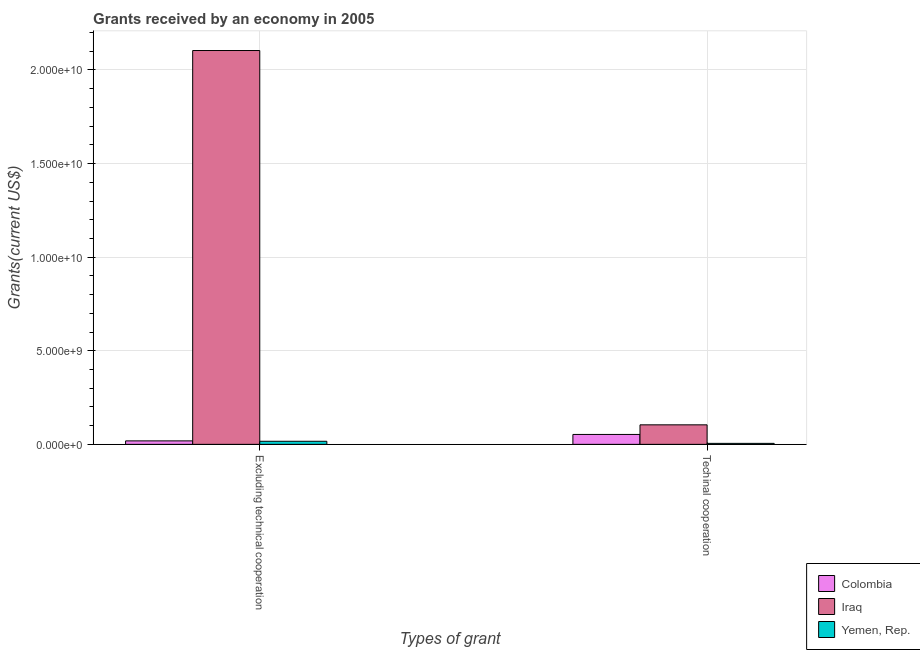How many bars are there on the 2nd tick from the left?
Offer a very short reply. 3. How many bars are there on the 1st tick from the right?
Ensure brevity in your answer.  3. What is the label of the 2nd group of bars from the left?
Your response must be concise. Techinal cooperation. What is the amount of grants received(excluding technical cooperation) in Colombia?
Provide a succinct answer. 1.86e+08. Across all countries, what is the maximum amount of grants received(excluding technical cooperation)?
Ensure brevity in your answer.  2.10e+1. Across all countries, what is the minimum amount of grants received(excluding technical cooperation)?
Keep it short and to the point. 1.65e+08. In which country was the amount of grants received(excluding technical cooperation) maximum?
Keep it short and to the point. Iraq. In which country was the amount of grants received(excluding technical cooperation) minimum?
Provide a short and direct response. Yemen, Rep. What is the total amount of grants received(excluding technical cooperation) in the graph?
Provide a short and direct response. 2.14e+1. What is the difference between the amount of grants received(excluding technical cooperation) in Colombia and that in Yemen, Rep.?
Give a very brief answer. 2.10e+07. What is the difference between the amount of grants received(including technical cooperation) in Colombia and the amount of grants received(excluding technical cooperation) in Yemen, Rep.?
Your response must be concise. 3.65e+08. What is the average amount of grants received(excluding technical cooperation) per country?
Your response must be concise. 7.13e+09. What is the difference between the amount of grants received(including technical cooperation) and amount of grants received(excluding technical cooperation) in Yemen, Rep.?
Make the answer very short. -1.12e+08. In how many countries, is the amount of grants received(including technical cooperation) greater than 12000000000 US$?
Provide a succinct answer. 0. What is the ratio of the amount of grants received(including technical cooperation) in Colombia to that in Iraq?
Make the answer very short. 0.51. In how many countries, is the amount of grants received(excluding technical cooperation) greater than the average amount of grants received(excluding technical cooperation) taken over all countries?
Your response must be concise. 1. What does the 1st bar from the left in Techinal cooperation represents?
Keep it short and to the point. Colombia. What does the 3rd bar from the right in Excluding technical cooperation represents?
Your answer should be very brief. Colombia. Are all the bars in the graph horizontal?
Ensure brevity in your answer.  No. How many countries are there in the graph?
Offer a terse response. 3. What is the difference between two consecutive major ticks on the Y-axis?
Give a very brief answer. 5.00e+09. Are the values on the major ticks of Y-axis written in scientific E-notation?
Keep it short and to the point. Yes. Does the graph contain any zero values?
Ensure brevity in your answer.  No. Where does the legend appear in the graph?
Provide a short and direct response. Bottom right. How many legend labels are there?
Ensure brevity in your answer.  3. What is the title of the graph?
Keep it short and to the point. Grants received by an economy in 2005. What is the label or title of the X-axis?
Ensure brevity in your answer.  Types of grant. What is the label or title of the Y-axis?
Give a very brief answer. Grants(current US$). What is the Grants(current US$) of Colombia in Excluding technical cooperation?
Provide a short and direct response. 1.86e+08. What is the Grants(current US$) in Iraq in Excluding technical cooperation?
Your response must be concise. 2.10e+1. What is the Grants(current US$) of Yemen, Rep. in Excluding technical cooperation?
Provide a short and direct response. 1.65e+08. What is the Grants(current US$) of Colombia in Techinal cooperation?
Provide a succinct answer. 5.30e+08. What is the Grants(current US$) of Iraq in Techinal cooperation?
Offer a terse response. 1.04e+09. What is the Grants(current US$) of Yemen, Rep. in Techinal cooperation?
Your answer should be very brief. 5.33e+07. Across all Types of grant, what is the maximum Grants(current US$) in Colombia?
Provide a succinct answer. 5.30e+08. Across all Types of grant, what is the maximum Grants(current US$) in Iraq?
Provide a succinct answer. 2.10e+1. Across all Types of grant, what is the maximum Grants(current US$) of Yemen, Rep.?
Provide a succinct answer. 1.65e+08. Across all Types of grant, what is the minimum Grants(current US$) of Colombia?
Your answer should be compact. 1.86e+08. Across all Types of grant, what is the minimum Grants(current US$) in Iraq?
Your answer should be compact. 1.04e+09. Across all Types of grant, what is the minimum Grants(current US$) of Yemen, Rep.?
Provide a short and direct response. 5.33e+07. What is the total Grants(current US$) in Colombia in the graph?
Ensure brevity in your answer.  7.15e+08. What is the total Grants(current US$) of Iraq in the graph?
Provide a short and direct response. 2.21e+1. What is the total Grants(current US$) of Yemen, Rep. in the graph?
Your response must be concise. 2.18e+08. What is the difference between the Grants(current US$) of Colombia in Excluding technical cooperation and that in Techinal cooperation?
Give a very brief answer. -3.44e+08. What is the difference between the Grants(current US$) of Iraq in Excluding technical cooperation and that in Techinal cooperation?
Offer a very short reply. 2.00e+1. What is the difference between the Grants(current US$) in Yemen, Rep. in Excluding technical cooperation and that in Techinal cooperation?
Ensure brevity in your answer.  1.12e+08. What is the difference between the Grants(current US$) of Colombia in Excluding technical cooperation and the Grants(current US$) of Iraq in Techinal cooperation?
Offer a very short reply. -8.57e+08. What is the difference between the Grants(current US$) of Colombia in Excluding technical cooperation and the Grants(current US$) of Yemen, Rep. in Techinal cooperation?
Your response must be concise. 1.33e+08. What is the difference between the Grants(current US$) in Iraq in Excluding technical cooperation and the Grants(current US$) in Yemen, Rep. in Techinal cooperation?
Make the answer very short. 2.10e+1. What is the average Grants(current US$) in Colombia per Types of grant?
Your answer should be compact. 3.58e+08. What is the average Grants(current US$) of Iraq per Types of grant?
Provide a succinct answer. 1.10e+1. What is the average Grants(current US$) of Yemen, Rep. per Types of grant?
Provide a succinct answer. 1.09e+08. What is the difference between the Grants(current US$) of Colombia and Grants(current US$) of Iraq in Excluding technical cooperation?
Your answer should be very brief. -2.09e+1. What is the difference between the Grants(current US$) of Colombia and Grants(current US$) of Yemen, Rep. in Excluding technical cooperation?
Your answer should be compact. 2.10e+07. What is the difference between the Grants(current US$) in Iraq and Grants(current US$) in Yemen, Rep. in Excluding technical cooperation?
Keep it short and to the point. 2.09e+1. What is the difference between the Grants(current US$) of Colombia and Grants(current US$) of Iraq in Techinal cooperation?
Provide a short and direct response. -5.14e+08. What is the difference between the Grants(current US$) in Colombia and Grants(current US$) in Yemen, Rep. in Techinal cooperation?
Provide a short and direct response. 4.76e+08. What is the difference between the Grants(current US$) in Iraq and Grants(current US$) in Yemen, Rep. in Techinal cooperation?
Keep it short and to the point. 9.90e+08. What is the ratio of the Grants(current US$) of Colombia in Excluding technical cooperation to that in Techinal cooperation?
Offer a very short reply. 0.35. What is the ratio of the Grants(current US$) in Iraq in Excluding technical cooperation to that in Techinal cooperation?
Give a very brief answer. 20.17. What is the ratio of the Grants(current US$) of Yemen, Rep. in Excluding technical cooperation to that in Techinal cooperation?
Ensure brevity in your answer.  3.09. What is the difference between the highest and the second highest Grants(current US$) of Colombia?
Keep it short and to the point. 3.44e+08. What is the difference between the highest and the second highest Grants(current US$) of Iraq?
Give a very brief answer. 2.00e+1. What is the difference between the highest and the second highest Grants(current US$) in Yemen, Rep.?
Make the answer very short. 1.12e+08. What is the difference between the highest and the lowest Grants(current US$) in Colombia?
Your response must be concise. 3.44e+08. What is the difference between the highest and the lowest Grants(current US$) of Iraq?
Give a very brief answer. 2.00e+1. What is the difference between the highest and the lowest Grants(current US$) of Yemen, Rep.?
Offer a very short reply. 1.12e+08. 